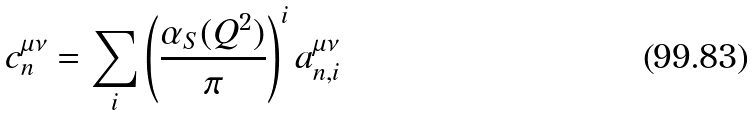Convert formula to latex. <formula><loc_0><loc_0><loc_500><loc_500>c _ { n } ^ { \mu \nu } = \sum _ { i } \left ( \frac { \alpha _ { S } ( Q ^ { 2 } ) } { \pi } \right ) ^ { i } a _ { n , i } ^ { \mu \nu }</formula> 